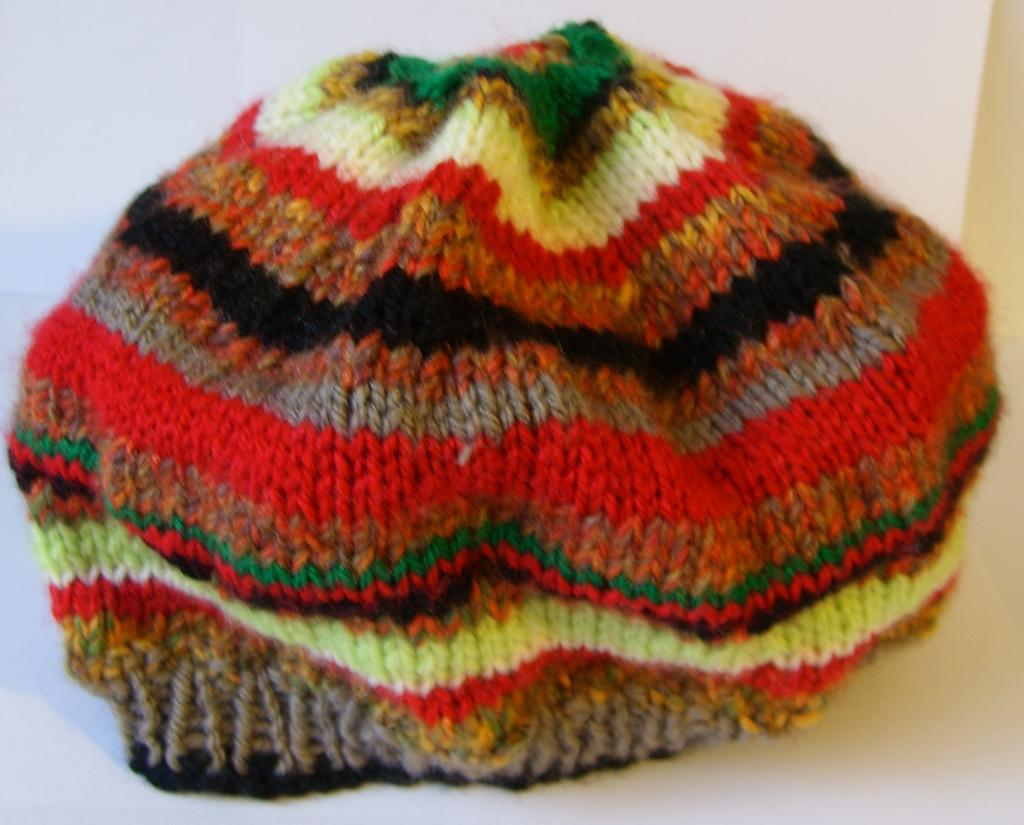What type of headwear is present in the image? There is a woolen cap in the image. Can you describe the appearance of the woolen cap? The woolen cap has different colors. What type of alarm can be heard going off in the image? There is no alarm present in the image; it is a still image of a woolen cap. 